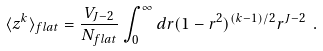Convert formula to latex. <formula><loc_0><loc_0><loc_500><loc_500>\langle z ^ { k } \rangle _ { f l a t } = \frac { V _ { J - 2 } } { N _ { f l a t } } \int _ { 0 } ^ { \infty } d r ( 1 - r ^ { 2 } ) ^ { ( k - 1 ) / 2 } r ^ { J - 2 } \ .</formula> 